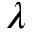<formula> <loc_0><loc_0><loc_500><loc_500>\lambda</formula> 